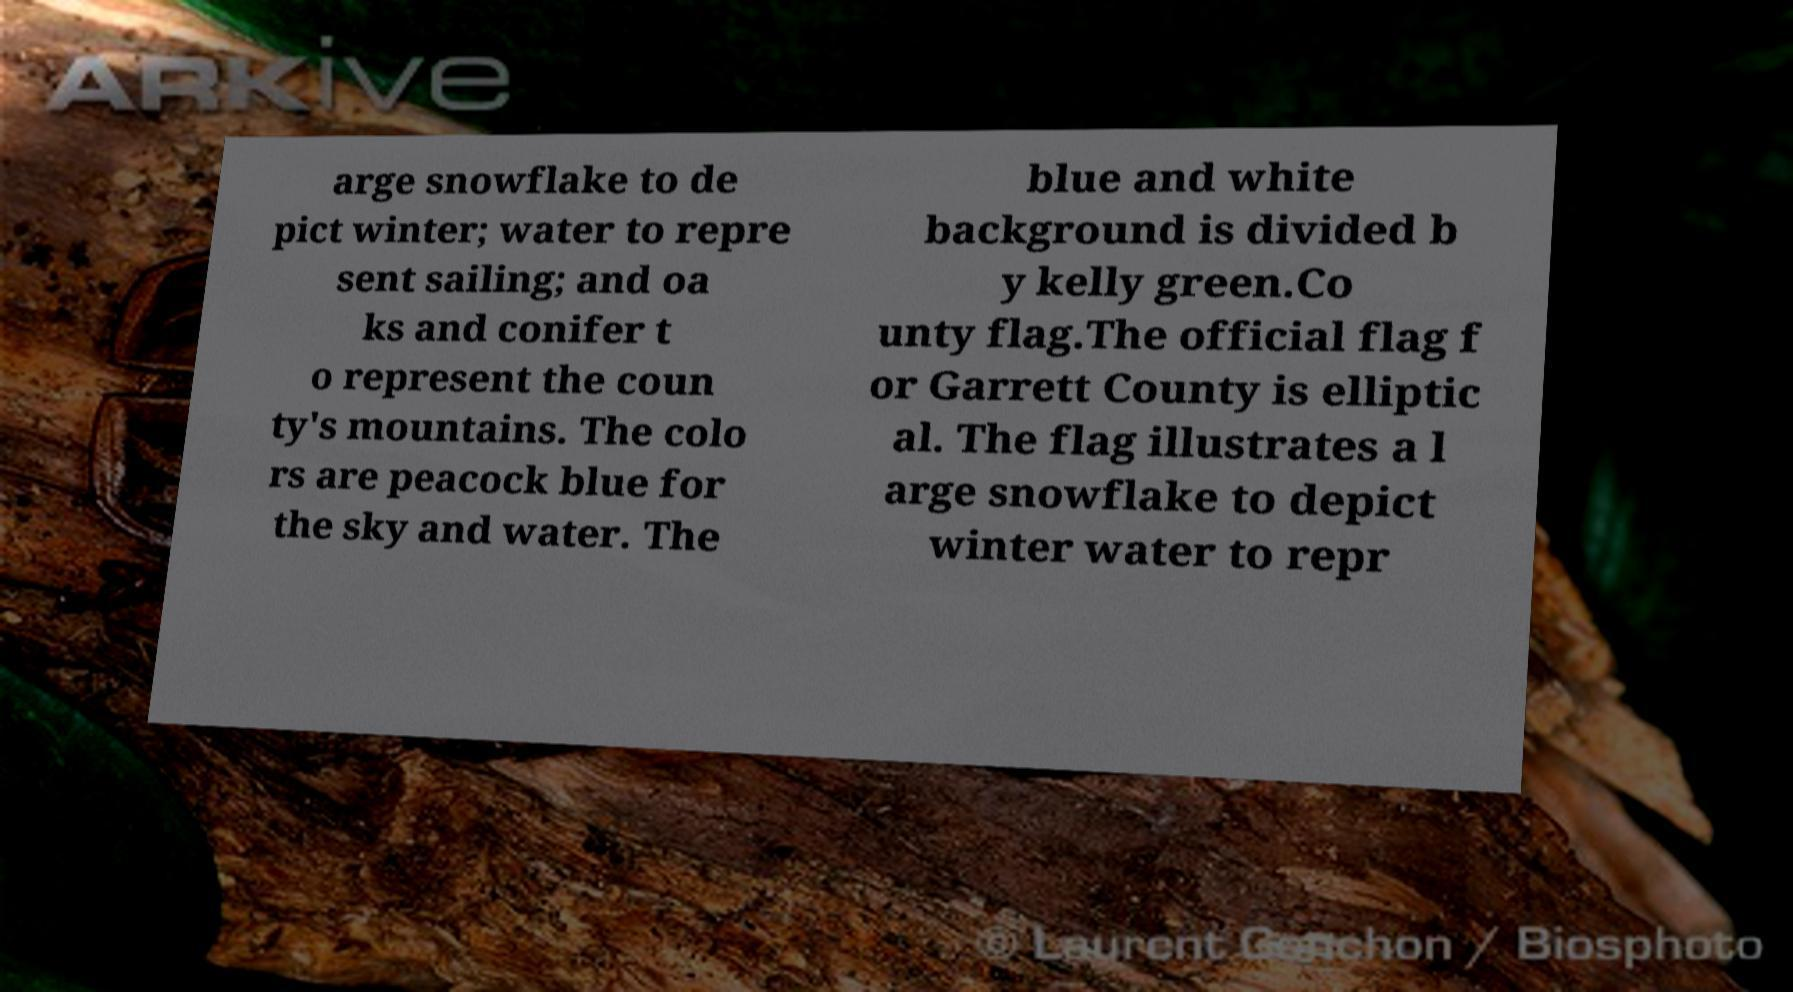Can you accurately transcribe the text from the provided image for me? arge snowflake to de pict winter; water to repre sent sailing; and oa ks and conifer t o represent the coun ty's mountains. The colo rs are peacock blue for the sky and water. The blue and white background is divided b y kelly green.Co unty flag.The official flag f or Garrett County is elliptic al. The flag illustrates a l arge snowflake to depict winter water to repr 